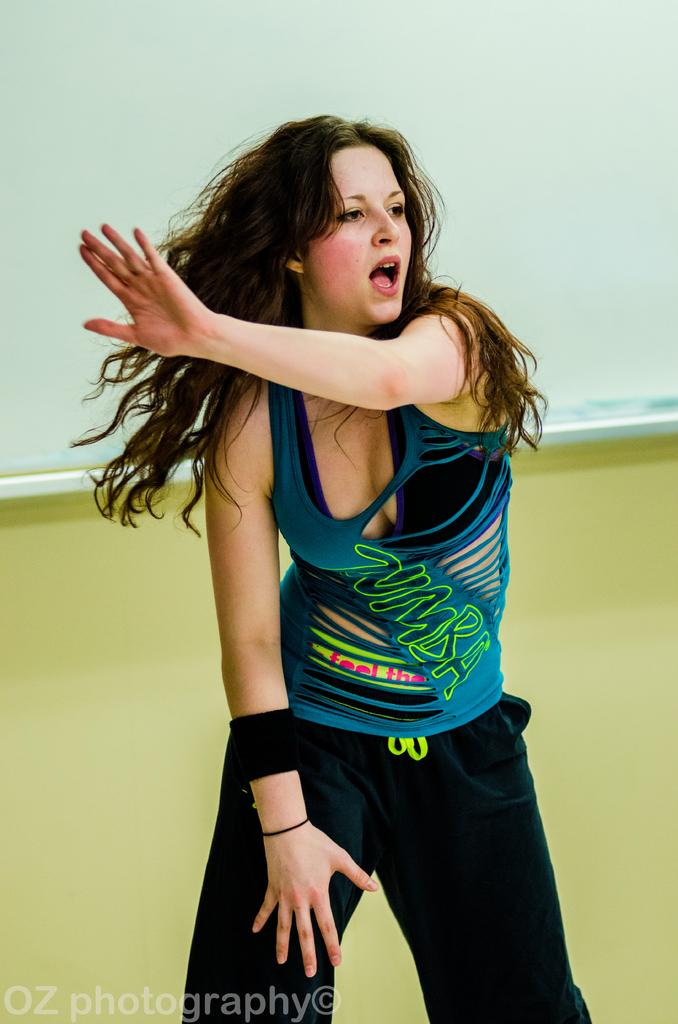Who is the main subject in the image? There is a woman in the image. What is the woman wearing? The woman is wearing a dress. Where is the woman located in the image? The woman is standing on the floor. What can be seen at the bottom of the image? There is text visible at the bottom of the image. What is visible in the background of the image? There is a wall in the background of the image. How many bananas are being offered for peace in the image? There are no bananas or references to peace in the image. 